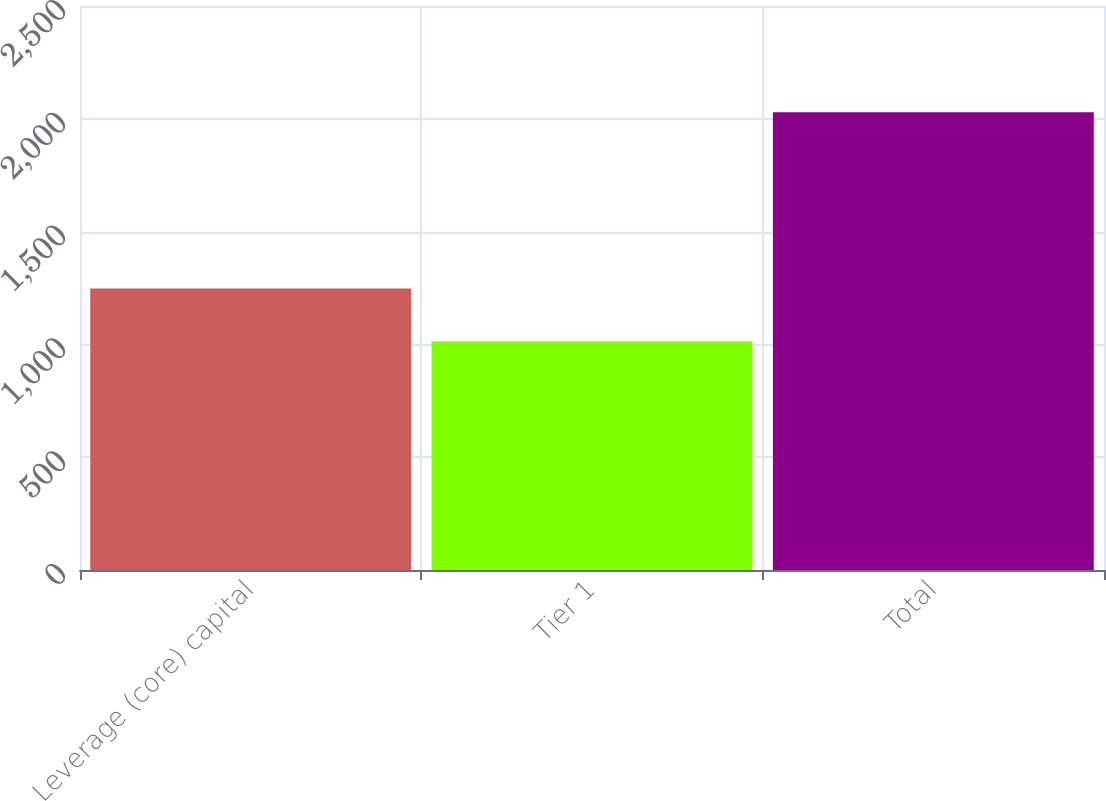<chart> <loc_0><loc_0><loc_500><loc_500><bar_chart><fcel>Leverage (core) capital<fcel>Tier 1<fcel>Total<nl><fcel>1247.9<fcel>1014.3<fcel>2028.5<nl></chart> 